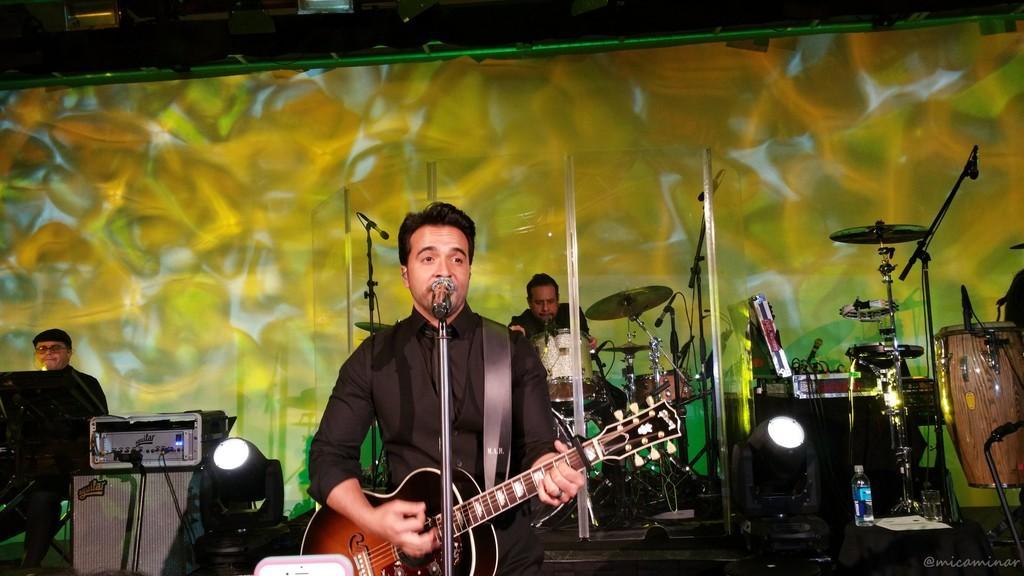How would you summarize this image in a sentence or two? On the background we can see screen. Here we can see a man in front of a mike and playing guitar. We can see drums , cymbal. This is a bottle. At the left side of the picture we can see a man sitting wearing a cap. This is an electronic device. These are lights. 